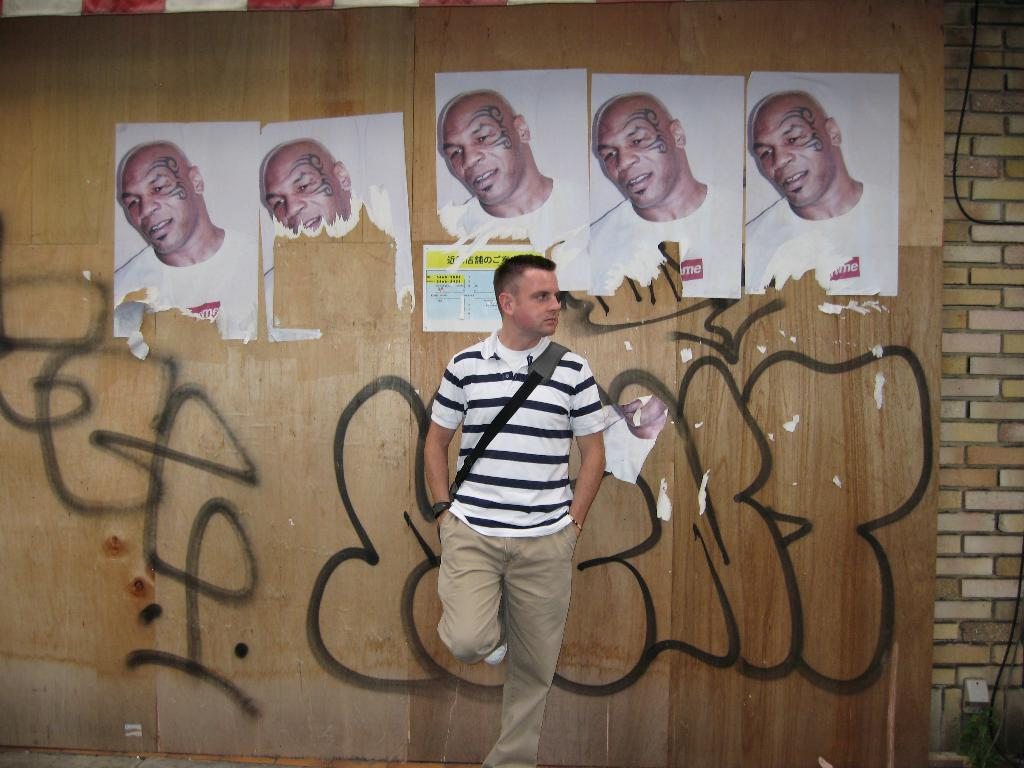What is the man in the image doing near the wall? The man is standing near the wall, with one leg on the wall. What can be seen on the wall in the image? There are photos of a man on the wall. What is at the bottom of the wall in the image? There is some drawing at the bottom of the wall. What type of writing can be seen on the calculator in the image? There is no calculator present in the image. 